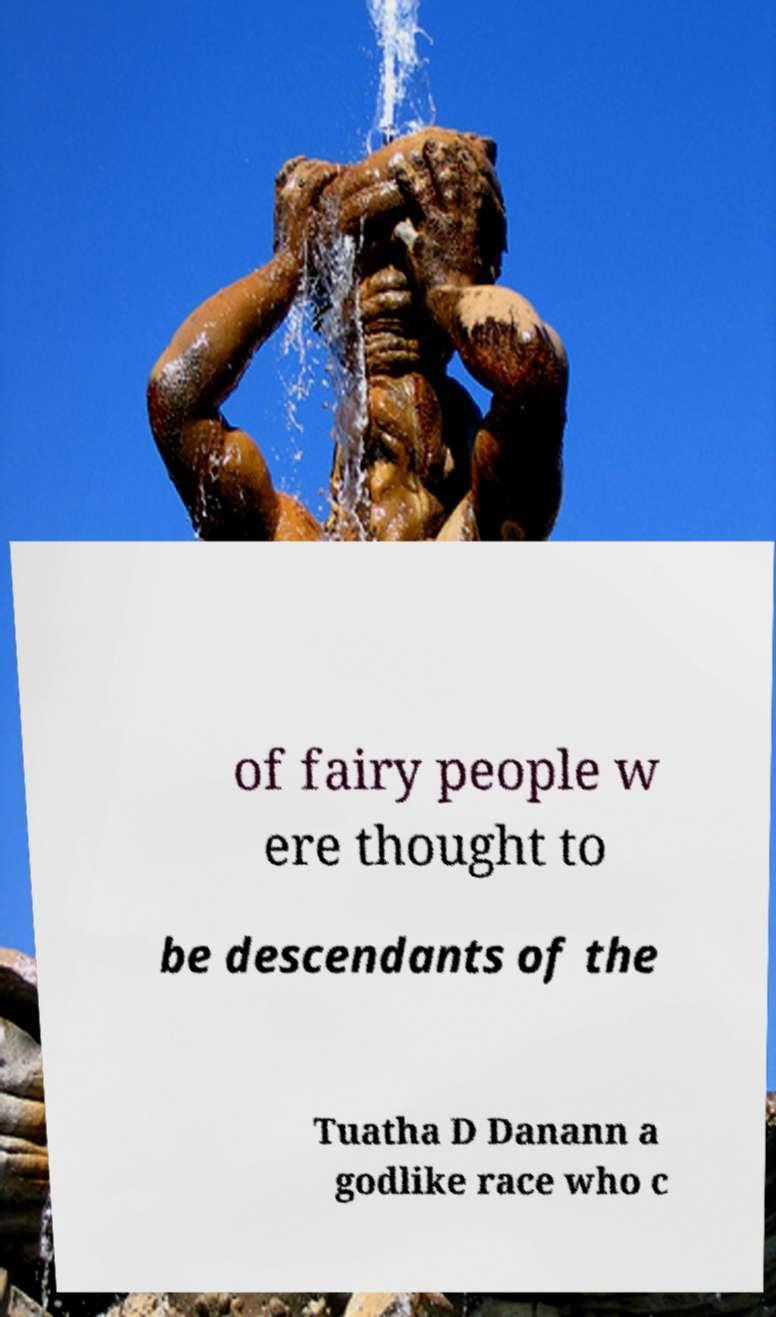Could you extract and type out the text from this image? of fairy people w ere thought to be descendants of the Tuatha D Danann a godlike race who c 